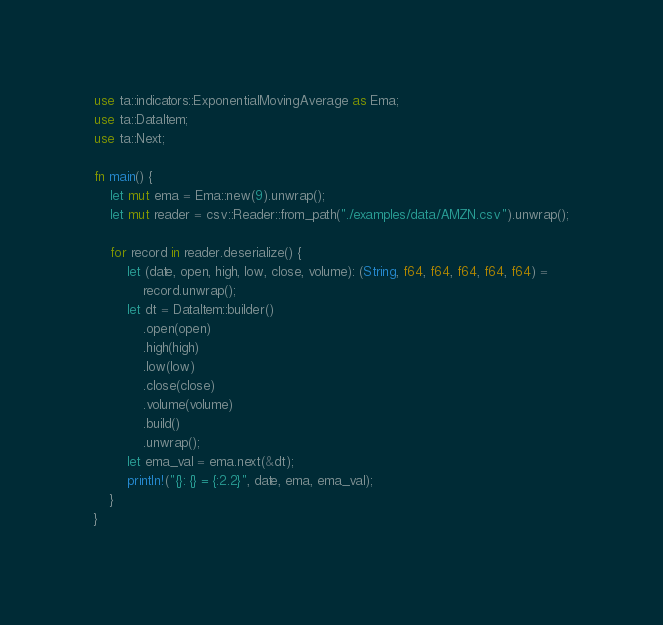Convert code to text. <code><loc_0><loc_0><loc_500><loc_500><_Rust_>use ta::indicators::ExponentialMovingAverage as Ema;
use ta::DataItem;
use ta::Next;

fn main() {
    let mut ema = Ema::new(9).unwrap();
    let mut reader = csv::Reader::from_path("./examples/data/AMZN.csv").unwrap();

    for record in reader.deserialize() {
        let (date, open, high, low, close, volume): (String, f64, f64, f64, f64, f64) =
            record.unwrap();
        let dt = DataItem::builder()
            .open(open)
            .high(high)
            .low(low)
            .close(close)
            .volume(volume)
            .build()
            .unwrap();
        let ema_val = ema.next(&dt);
        println!("{}: {} = {:2.2}", date, ema, ema_val);
    }
}
</code> 